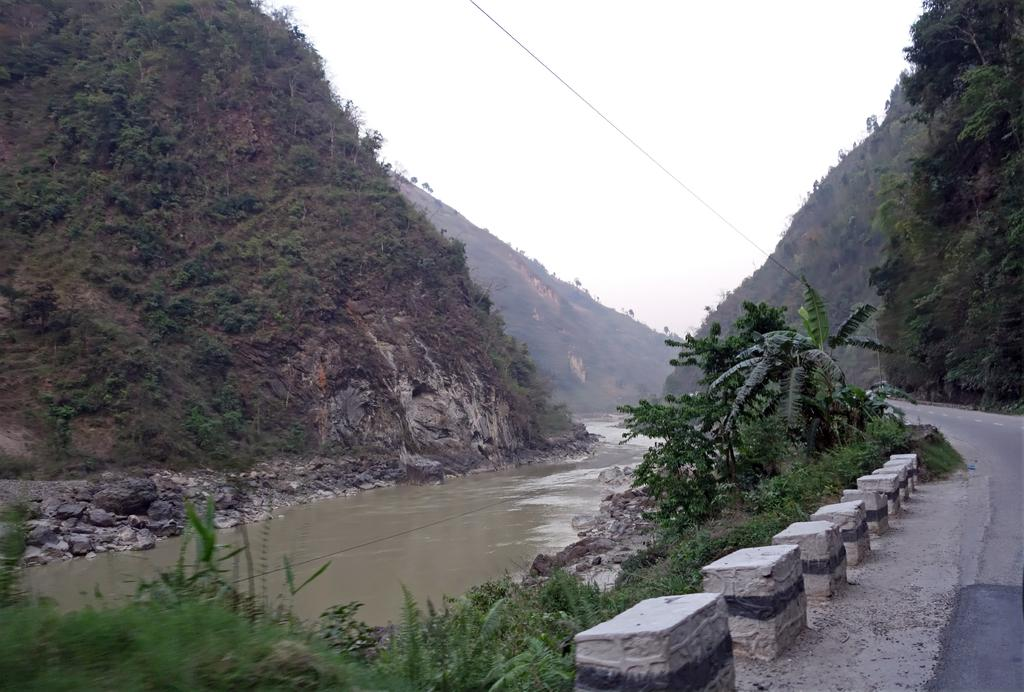What type of natural environment is depicted in the image? The image features water, grass, plants, trees, and mountains, which are all elements of a natural environment. What type of surface can be seen in the image? There is a road in the image. What is visible in the background of the image? The sky is visible in the background of the image. What type of design can be seen on the duck's feathers in the image? There are no ducks present in the image, so there is no duck design to observe. Is there any blood visible in the image? There is no blood visible in the image; the image features natural elements such as water, grass, plants, trees, and mountains. 